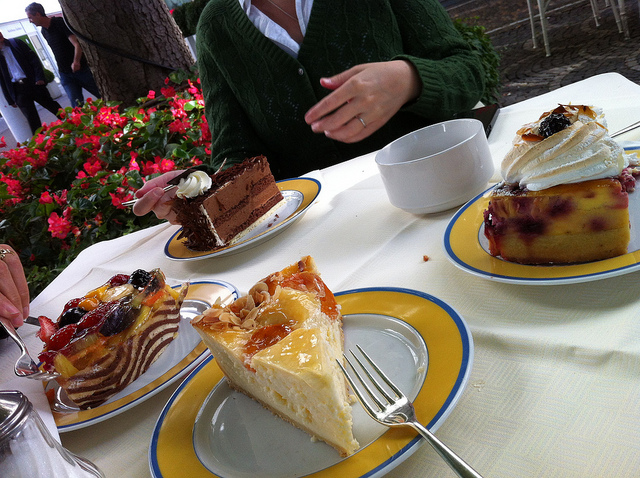What types of cakes can you identify on the table? The table showcases an assortment of cakes. There's a slice of what looks like creamy cheesecake topped with a glossy layer of glazed fruit. Next, there's a beautiful piece of chocolate layer cake adorned with a dollop of cream. Lastly, a decadent pastry topped with whipped cream and berries caps off this delightful trio. Each cake is ready to tempt the taste buds of anyone who takes a seat at this table. 